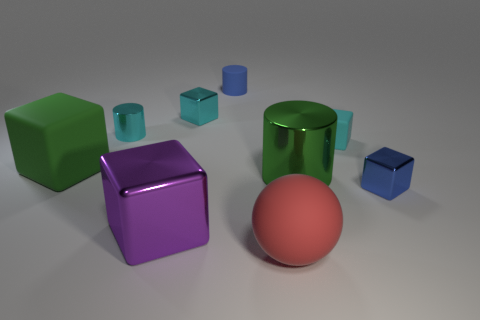How many red things are there?
Your response must be concise. 1. There is a cyan block to the left of the cylinder that is in front of the green matte thing; is there a small matte object that is on the left side of it?
Your response must be concise. No. What shape is the purple shiny thing that is the same size as the green matte object?
Give a very brief answer. Cube. How many other objects are the same color as the large metal cube?
Provide a short and direct response. 0. What is the material of the tiny blue block?
Provide a succinct answer. Metal. How many other things are made of the same material as the tiny cyan cylinder?
Give a very brief answer. 4. There is a cube that is on the right side of the ball and behind the blue shiny thing; what size is it?
Your answer should be compact. Small. There is a blue thing that is in front of the tiny cyan block right of the red matte sphere; what shape is it?
Offer a terse response. Cube. Is there any other thing that has the same shape as the big purple thing?
Offer a terse response. Yes. Are there the same number of small cyan shiny cubes to the right of the large green metallic cylinder and tiny metallic balls?
Keep it short and to the point. Yes. 